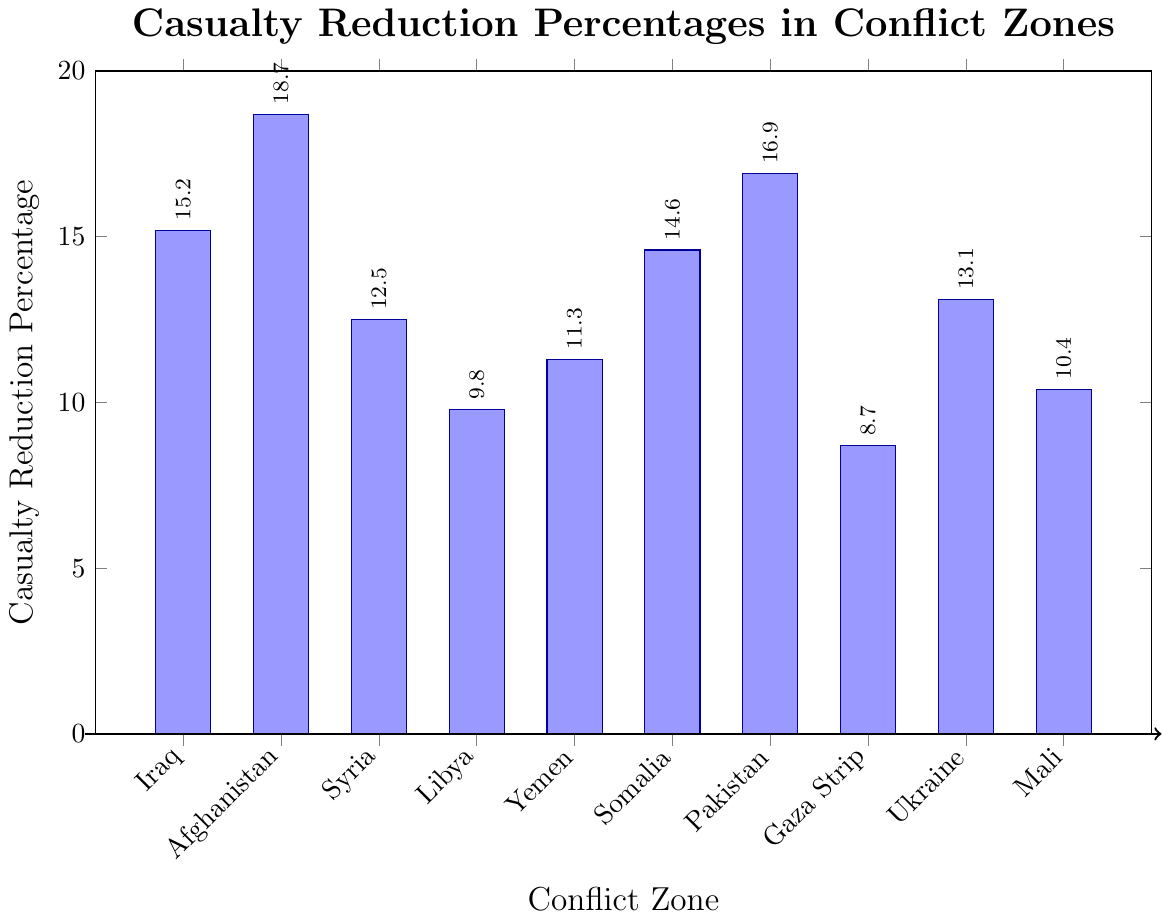Which conflict zone has the highest casualty reduction percentage? First, observe all the bars representing casualty reduction percentages for each conflict zone. Look for the tallest bar as it indicates the highest value. In this case, the tallest bar corresponds to Afghanistan with a value of 18.7%.
Answer: Afghanistan Which conflict zone has the lowest casualty reduction percentage? Identify the shortest bar in the chart which denotes the lowest casualty reduction percentage. The shortest bar corresponds to the Gaza Strip, with a value of 8.7%.
Answer: Gaza Strip How much higher is the casualty reduction percentage in Afghanistan compared to Syria? Look at the values for Afghanistan (18.7%) and Syria (12.5%). Subtract the percentage for Syria from that of Afghanistan: 18.7 - 12.5 = 6.2%.
Answer: 6.2% What is the average casualty reduction percentage across all conflict zones? Sum the percentages of all conflict zones: 15.2 + 18.7 + 12.5 + 9.8 + 11.3 + 14.6 + 16.9 + 8.7 + 13.1 + 10.4 = 131.2. Divide by the number of zones (10): 131.2 / 10 = 13.12%.
Answer: 13.12% How does the casualty reduction percentage in Somalia compare to that in Ukraine? Compare the bars for Somalia (14.6%) and Ukraine (13.1%). Somalia's percentage is higher.
Answer: Somalia Which conflict zone has a casualty reduction percentage closest to the average? The calculated average is 13.12%. Compare each conflict zone's percentage to this average. Ukraine (13.1%) is the closest to the average of 13.12%.
Answer: Ukraine Order the conflict zones from highest to lowest in terms of casualty reduction percentage. Arrange the zones based on the heights of their corresponding bars: Afghanistan (18.7%), Pakistan (16.9%), Iraq (15.2%), Somalia (14.6%), Ukraine (13.1%), Syria (12.5%), Yemen (11.3%), Mali (10.4%), Libya (9.8%), and Gaza Strip (8.7%).
Answer: Afghanistan, Pakistan, Iraq, Somalia, Ukraine, Syria, Yemen, Mali, Libya, Gaza Strip What is the total casualty reduction percentage for the conflicts in the Middle East (Iraq, Syria, Libya, Yemen, Gaza Strip)? Sum the percentages for the Middle East conflict zones: Iraq (15.2%) + Syria (12.5%) + Libya (9.8%) + Yemen (11.3%) + Gaza Strip (8.7%) = 57.5%.
Answer: 57.5% What is the ratio of the casualty reduction percentage in Pakistan to that in Mali? Divide the percentage for Pakistan (16.9%) by the percentage for Mali (10.4%): 16.9 / 10.4 ≈ 1.63.
Answer: 1.63 